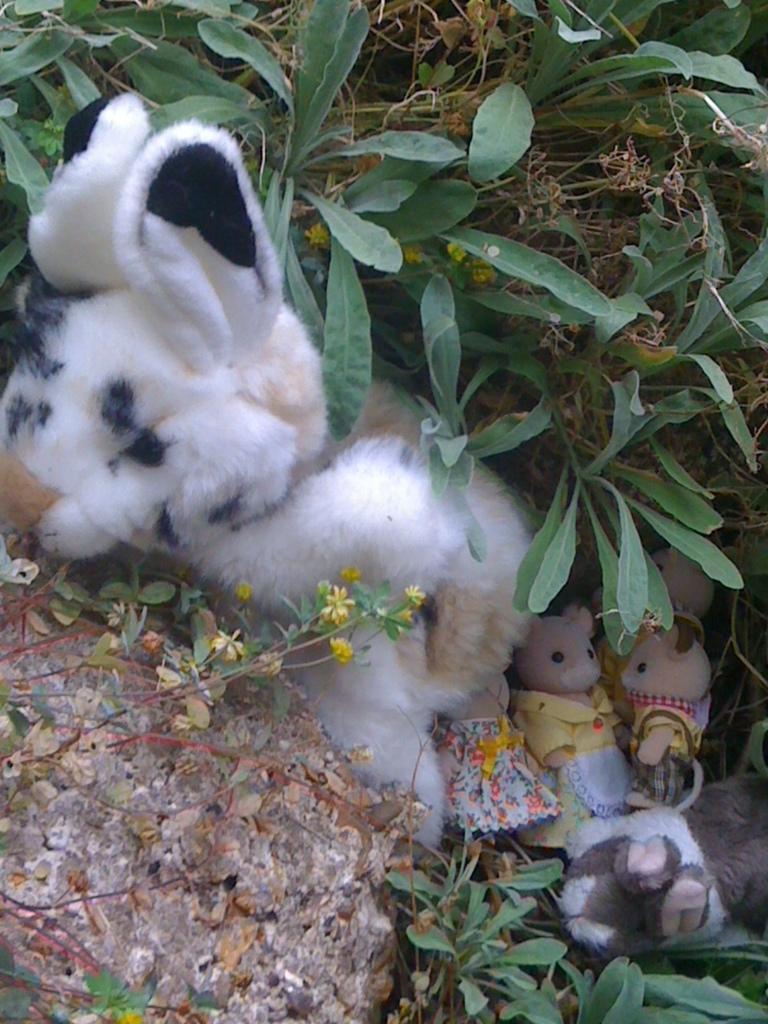How would you summarize this image in a sentence or two? In this picture we can see toys on the ground, here we can see a stone and in the background we can see plants. 